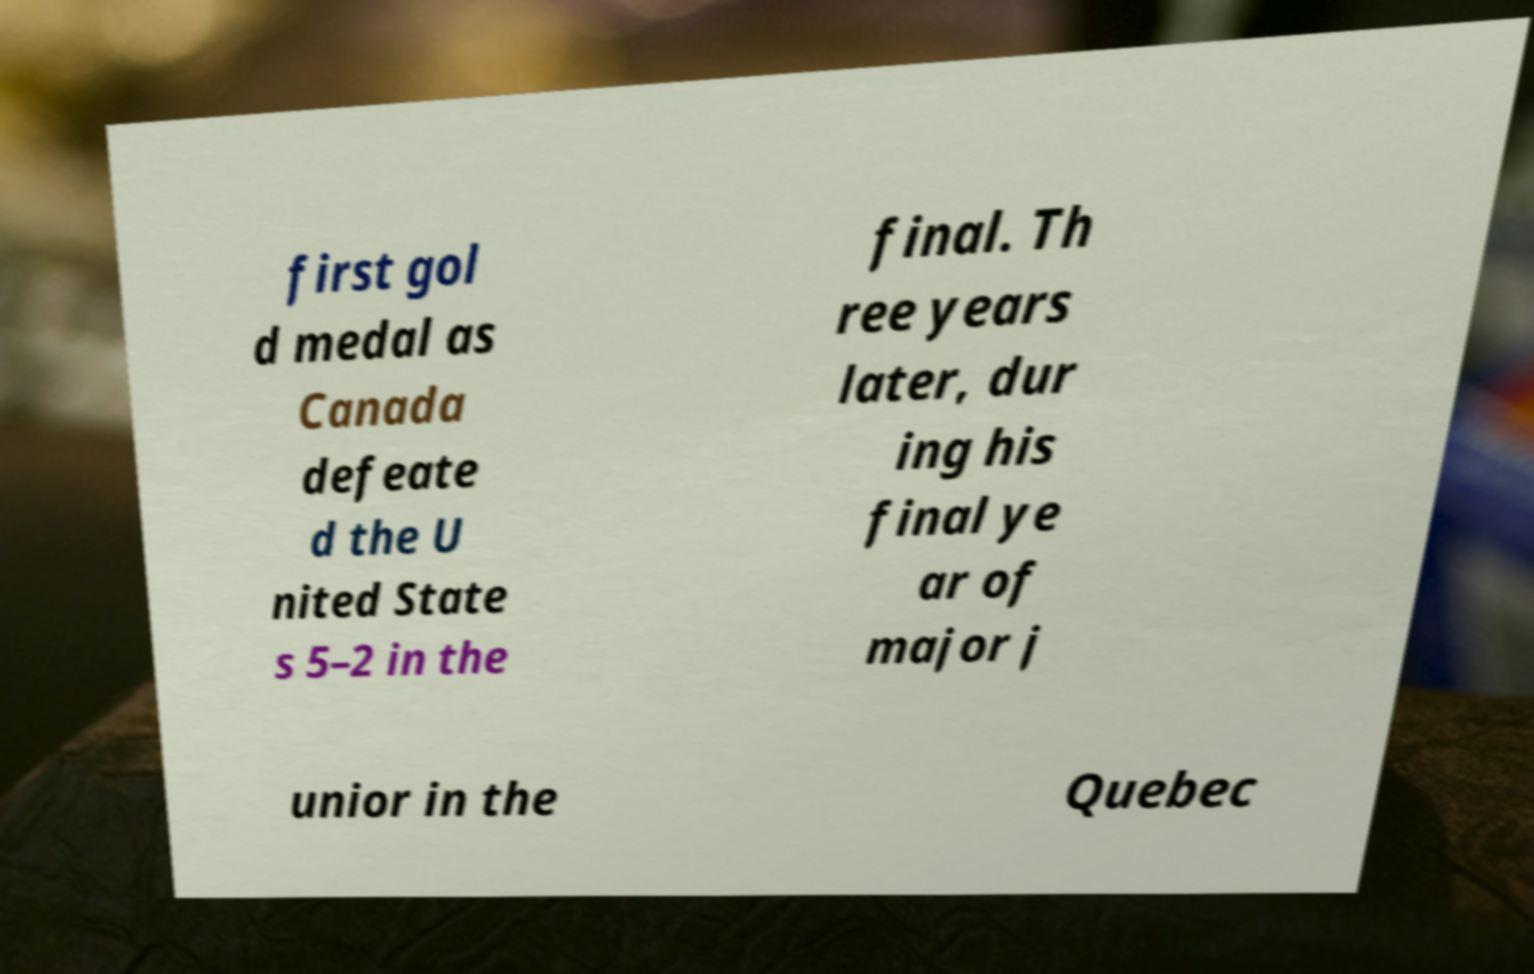Can you accurately transcribe the text from the provided image for me? first gol d medal as Canada defeate d the U nited State s 5–2 in the final. Th ree years later, dur ing his final ye ar of major j unior in the Quebec 